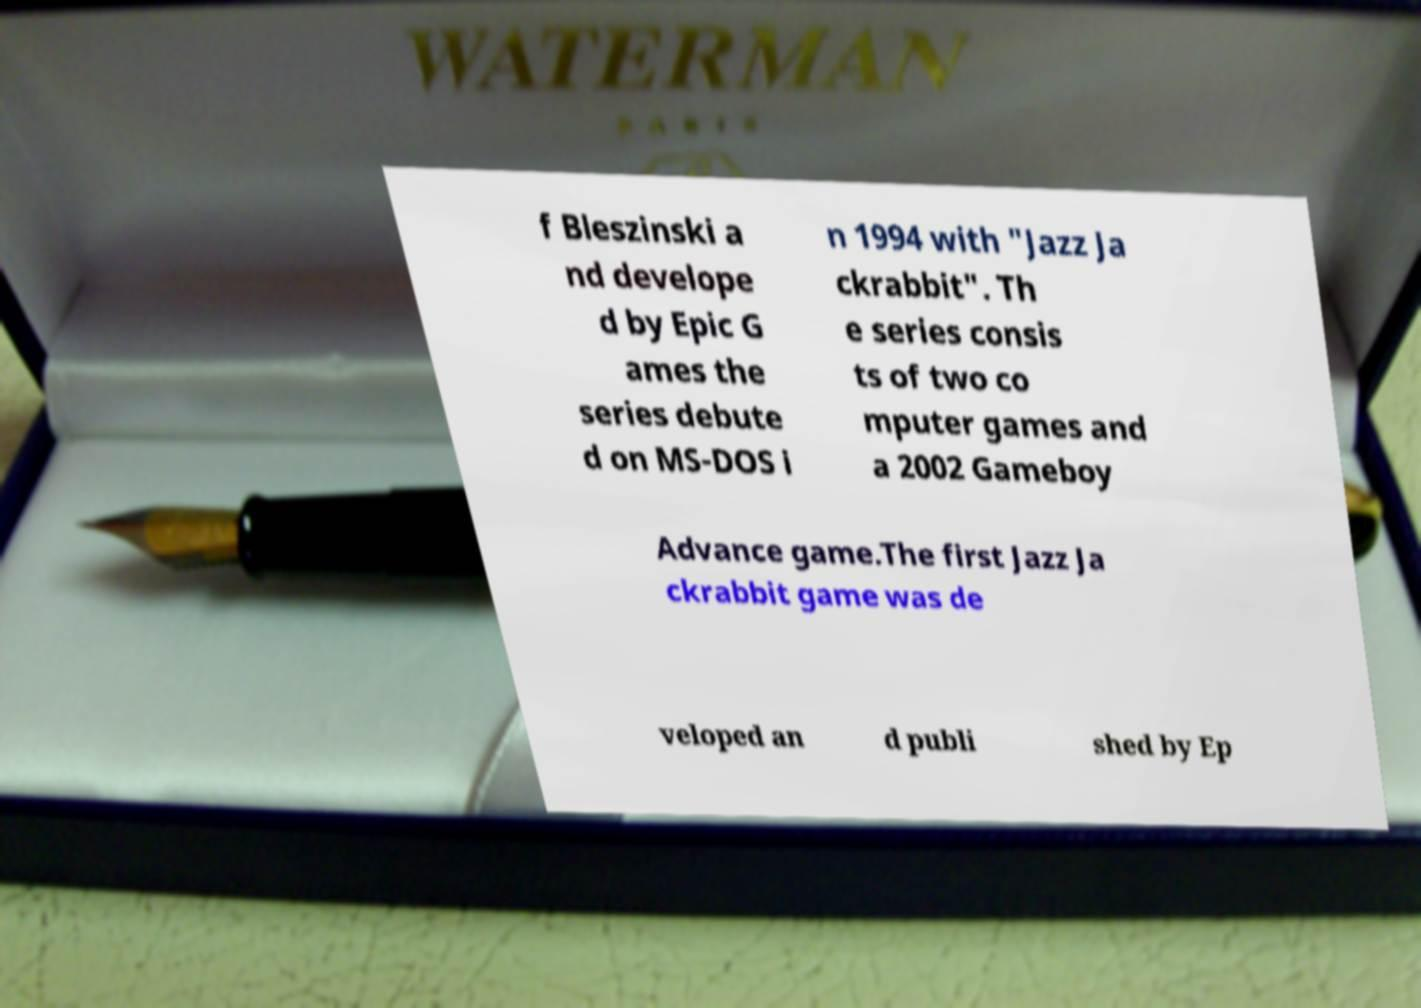I need the written content from this picture converted into text. Can you do that? f Bleszinski a nd develope d by Epic G ames the series debute d on MS-DOS i n 1994 with "Jazz Ja ckrabbit". Th e series consis ts of two co mputer games and a 2002 Gameboy Advance game.The first Jazz Ja ckrabbit game was de veloped an d publi shed by Ep 